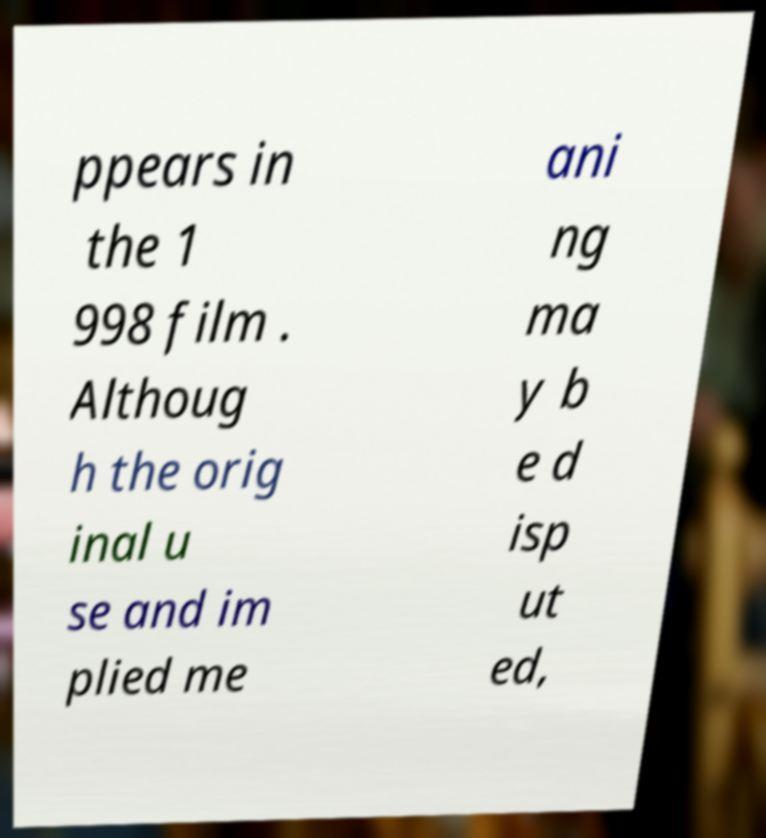Can you read and provide the text displayed in the image?This photo seems to have some interesting text. Can you extract and type it out for me? ppears in the 1 998 film . Althoug h the orig inal u se and im plied me ani ng ma y b e d isp ut ed, 